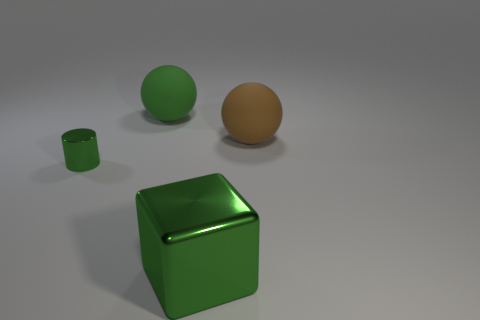Add 1 yellow things. How many objects exist? 5 Subtract all cylinders. How many objects are left? 3 Add 1 green cylinders. How many green cylinders exist? 2 Subtract 0 purple blocks. How many objects are left? 4 Subtract all purple matte cylinders. Subtract all large green matte things. How many objects are left? 3 Add 2 metallic things. How many metallic things are left? 4 